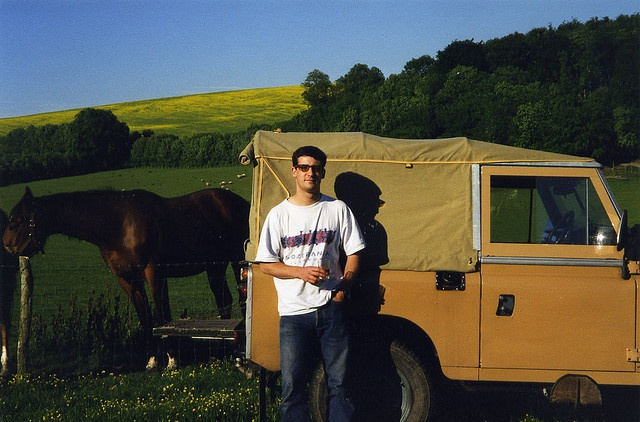Describe the objects in this image and their specific colors. I can see truck in gray, olive, and black tones, horse in gray, black, maroon, olive, and darkgreen tones, and people in gray, black, white, and tan tones in this image. 